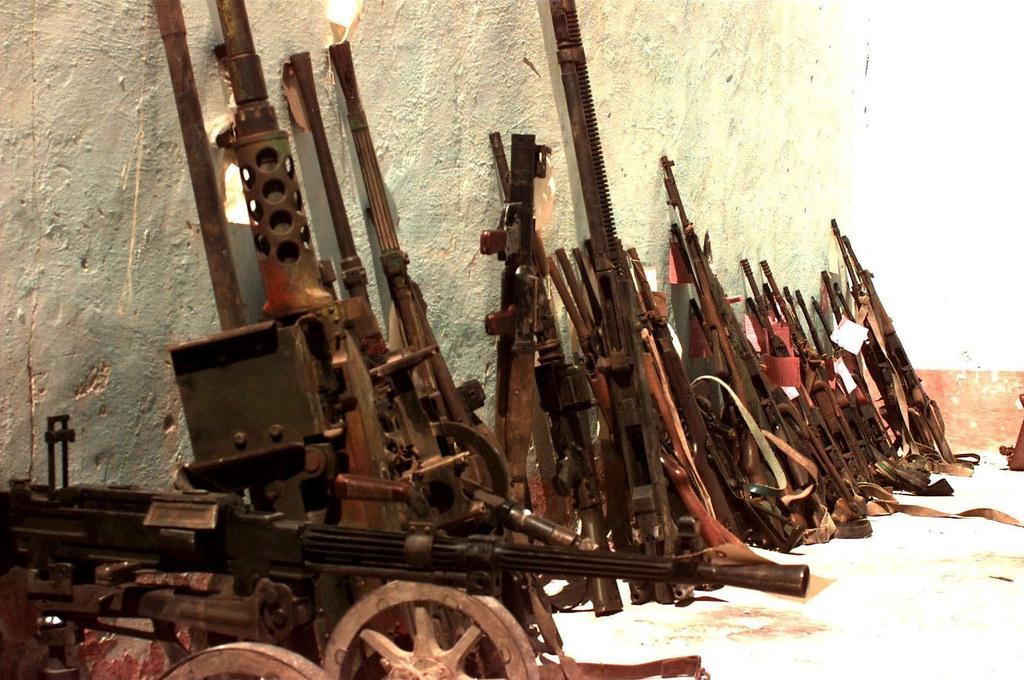Can you describe this image briefly? In this image there are many metal objects on the floor. Behind them there is a wall. 